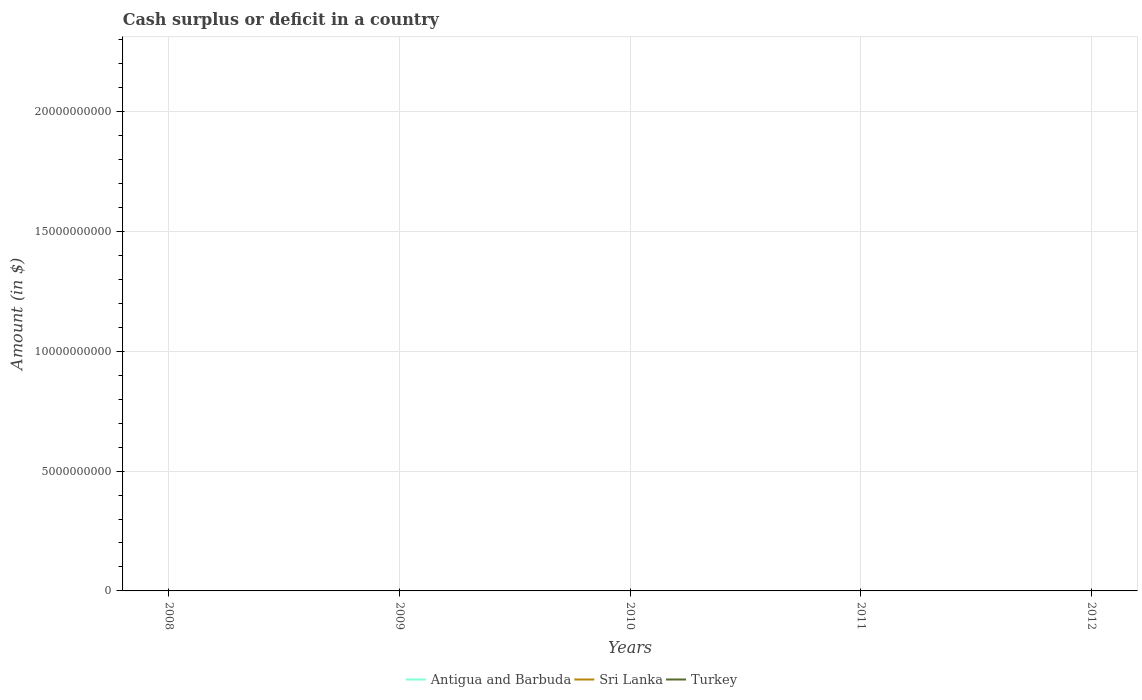Is the number of lines equal to the number of legend labels?
Provide a short and direct response. No. Across all years, what is the maximum amount of cash surplus or deficit in Antigua and Barbuda?
Make the answer very short. 0. What is the difference between the highest and the lowest amount of cash surplus or deficit in Sri Lanka?
Offer a very short reply. 0. How many lines are there?
Your response must be concise. 0. How many years are there in the graph?
Your answer should be compact. 5. What is the difference between two consecutive major ticks on the Y-axis?
Keep it short and to the point. 5.00e+09. Are the values on the major ticks of Y-axis written in scientific E-notation?
Keep it short and to the point. No. Does the graph contain any zero values?
Offer a terse response. Yes. Where does the legend appear in the graph?
Give a very brief answer. Bottom center. What is the title of the graph?
Keep it short and to the point. Cash surplus or deficit in a country. What is the label or title of the Y-axis?
Provide a short and direct response. Amount (in $). What is the Amount (in $) in Sri Lanka in 2008?
Keep it short and to the point. 0. What is the Amount (in $) of Turkey in 2008?
Provide a succinct answer. 0. What is the Amount (in $) in Antigua and Barbuda in 2011?
Provide a short and direct response. 0. What is the Amount (in $) of Sri Lanka in 2012?
Your answer should be very brief. 0. What is the total Amount (in $) of Sri Lanka in the graph?
Ensure brevity in your answer.  0. What is the total Amount (in $) in Turkey in the graph?
Your answer should be very brief. 0. What is the average Amount (in $) in Antigua and Barbuda per year?
Ensure brevity in your answer.  0. What is the average Amount (in $) of Sri Lanka per year?
Make the answer very short. 0. 